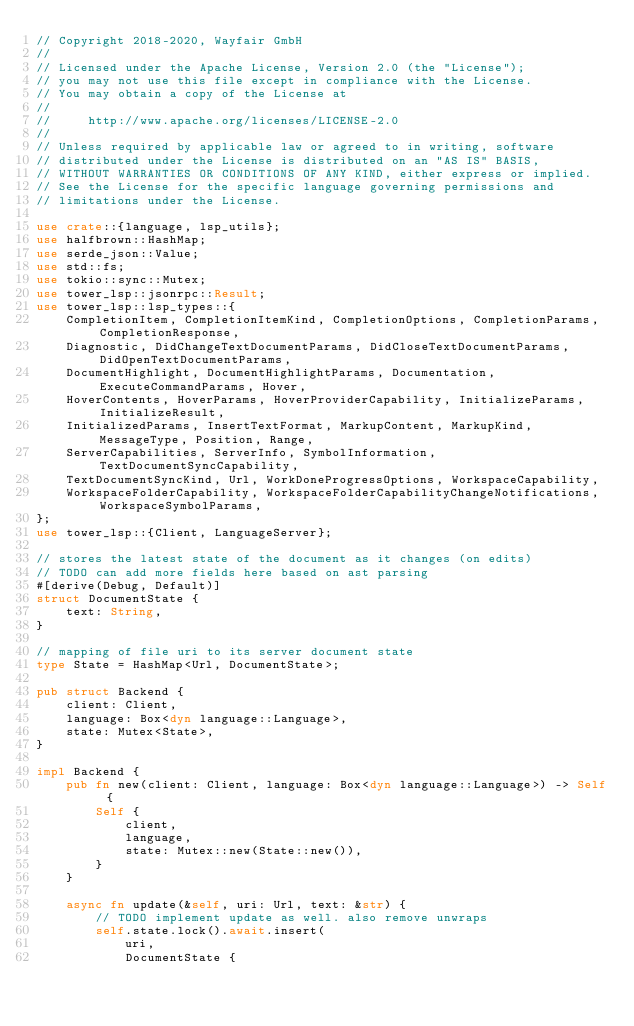Convert code to text. <code><loc_0><loc_0><loc_500><loc_500><_Rust_>// Copyright 2018-2020, Wayfair GmbH
//
// Licensed under the Apache License, Version 2.0 (the "License");
// you may not use this file except in compliance with the License.
// You may obtain a copy of the License at
//
//     http://www.apache.org/licenses/LICENSE-2.0
//
// Unless required by applicable law or agreed to in writing, software
// distributed under the License is distributed on an "AS IS" BASIS,
// WITHOUT WARRANTIES OR CONDITIONS OF ANY KIND, either express or implied.
// See the License for the specific language governing permissions and
// limitations under the License.

use crate::{language, lsp_utils};
use halfbrown::HashMap;
use serde_json::Value;
use std::fs;
use tokio::sync::Mutex;
use tower_lsp::jsonrpc::Result;
use tower_lsp::lsp_types::{
    CompletionItem, CompletionItemKind, CompletionOptions, CompletionParams, CompletionResponse,
    Diagnostic, DidChangeTextDocumentParams, DidCloseTextDocumentParams, DidOpenTextDocumentParams,
    DocumentHighlight, DocumentHighlightParams, Documentation, ExecuteCommandParams, Hover,
    HoverContents, HoverParams, HoverProviderCapability, InitializeParams, InitializeResult,
    InitializedParams, InsertTextFormat, MarkupContent, MarkupKind, MessageType, Position, Range,
    ServerCapabilities, ServerInfo, SymbolInformation, TextDocumentSyncCapability,
    TextDocumentSyncKind, Url, WorkDoneProgressOptions, WorkspaceCapability,
    WorkspaceFolderCapability, WorkspaceFolderCapabilityChangeNotifications, WorkspaceSymbolParams,
};
use tower_lsp::{Client, LanguageServer};

// stores the latest state of the document as it changes (on edits)
// TODO can add more fields here based on ast parsing
#[derive(Debug, Default)]
struct DocumentState {
    text: String,
}

// mapping of file uri to its server document state
type State = HashMap<Url, DocumentState>;

pub struct Backend {
    client: Client,
    language: Box<dyn language::Language>,
    state: Mutex<State>,
}

impl Backend {
    pub fn new(client: Client, language: Box<dyn language::Language>) -> Self {
        Self {
            client,
            language,
            state: Mutex::new(State::new()),
        }
    }

    async fn update(&self, uri: Url, text: &str) {
        // TODO implement update as well. also remove unwraps
        self.state.lock().await.insert(
            uri,
            DocumentState {</code> 